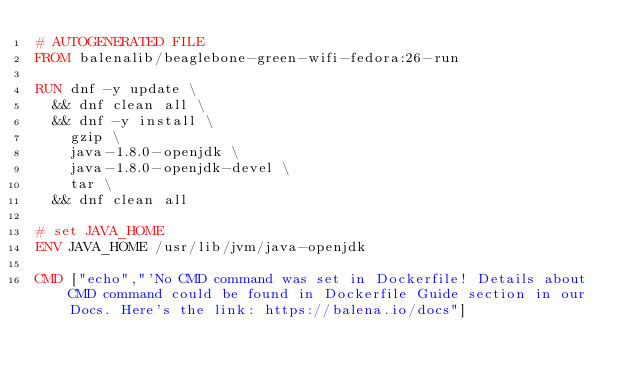Convert code to text. <code><loc_0><loc_0><loc_500><loc_500><_Dockerfile_># AUTOGENERATED FILE
FROM balenalib/beaglebone-green-wifi-fedora:26-run

RUN dnf -y update \
	&& dnf clean all \
	&& dnf -y install \
		gzip \
		java-1.8.0-openjdk \
		java-1.8.0-openjdk-devel \
		tar \
	&& dnf clean all

# set JAVA_HOME
ENV JAVA_HOME /usr/lib/jvm/java-openjdk

CMD ["echo","'No CMD command was set in Dockerfile! Details about CMD command could be found in Dockerfile Guide section in our Docs. Here's the link: https://balena.io/docs"]</code> 